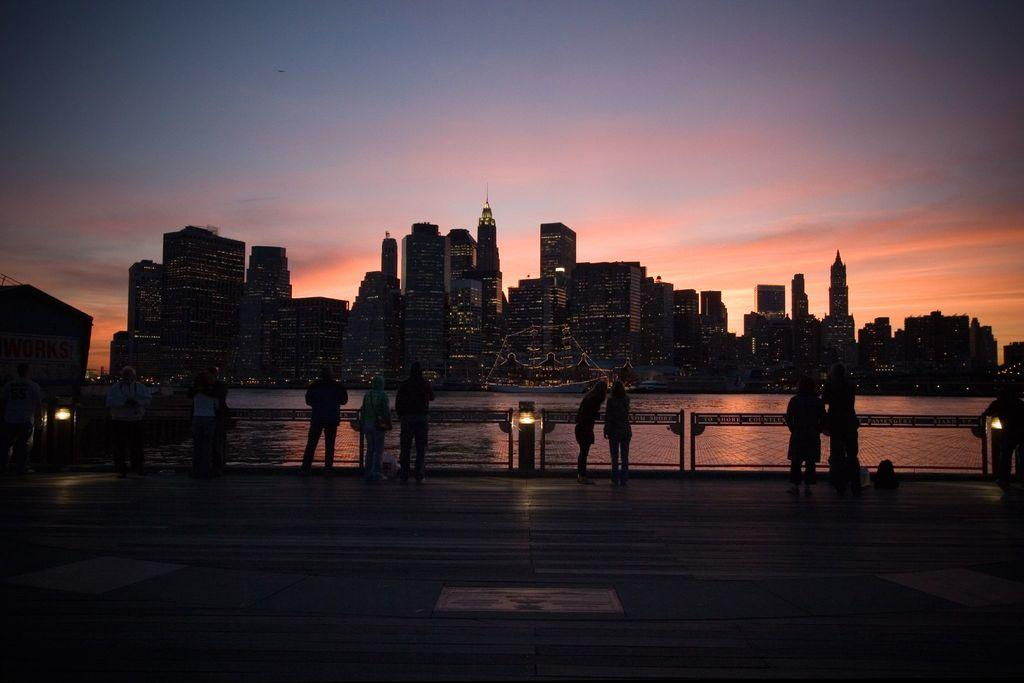What can be seen in the sky in the image? The sky with clouds is visible in the image. What type of structures are present in the image? There are buildings in the image. What natural feature is present in the image? There is a lake in the image. What type of lighting is present in the image? Electric lights are present in the image. What are the persons in the image doing? The persons are standing, holding railings, and holding backpacks. What is the position of the backpacks in the image? The backpacks are on the floor. What type of lace can be seen on the persons' clothing in the image? There is no lace visible on the persons' clothing in the image. What sound can be heard from the bells in the image? There are no bells present in the image, so no sound can be heard from them. 